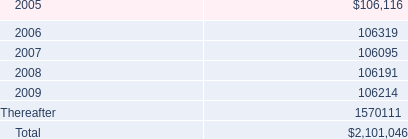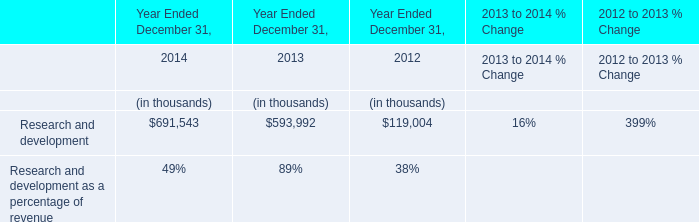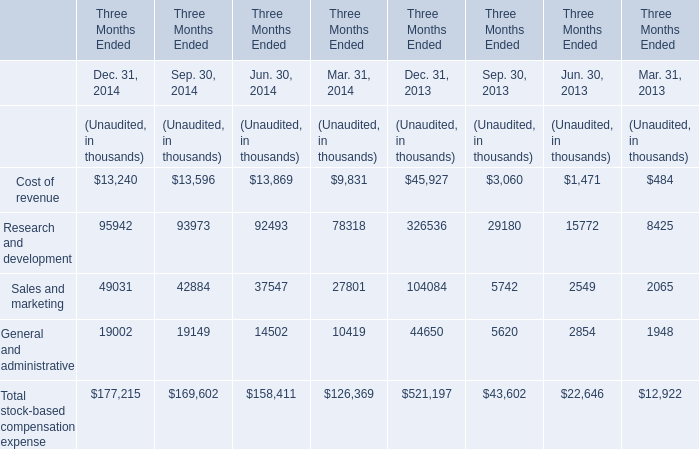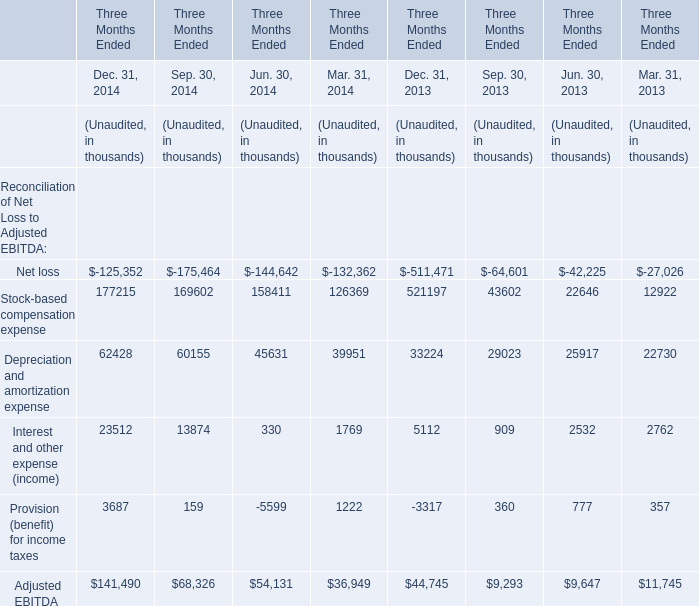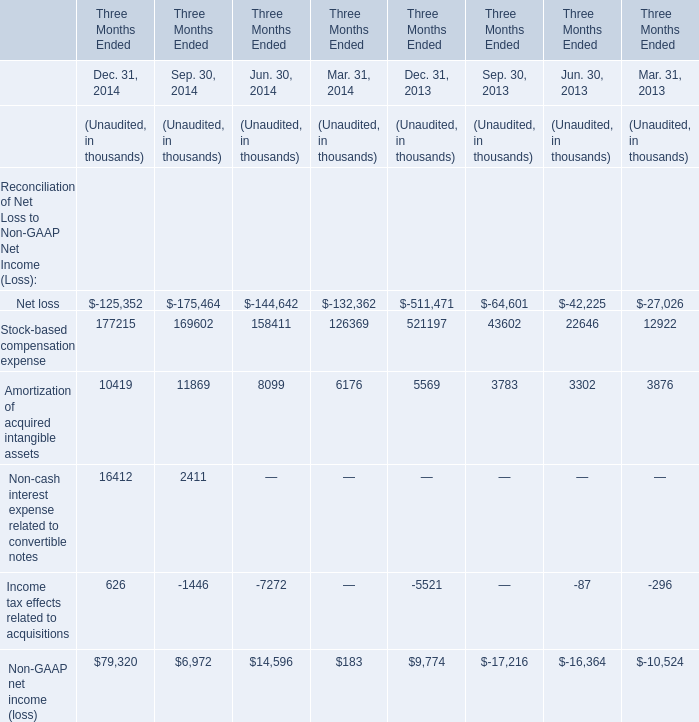Which element exceeds 90 % of total for Mar. 31, 2014? 
Answer: Stock-based compensation expense, Depreciation and amortization expense. 